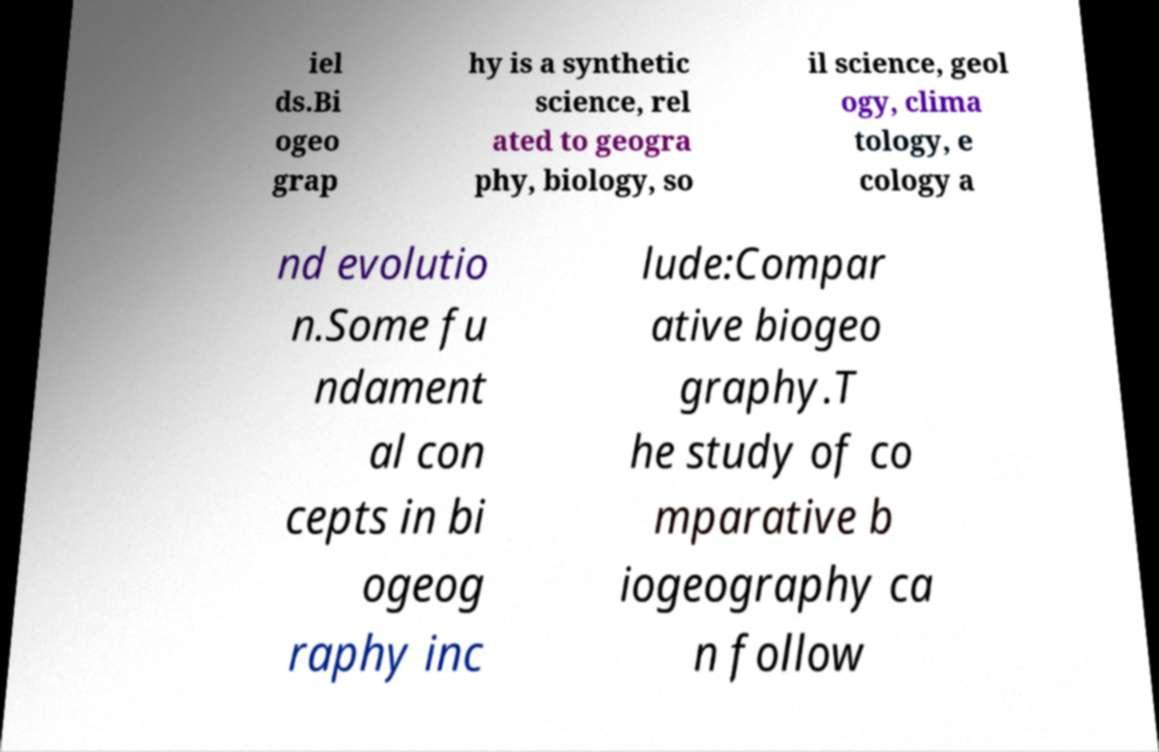There's text embedded in this image that I need extracted. Can you transcribe it verbatim? iel ds.Bi ogeo grap hy is a synthetic science, rel ated to geogra phy, biology, so il science, geol ogy, clima tology, e cology a nd evolutio n.Some fu ndament al con cepts in bi ogeog raphy inc lude:Compar ative biogeo graphy.T he study of co mparative b iogeography ca n follow 